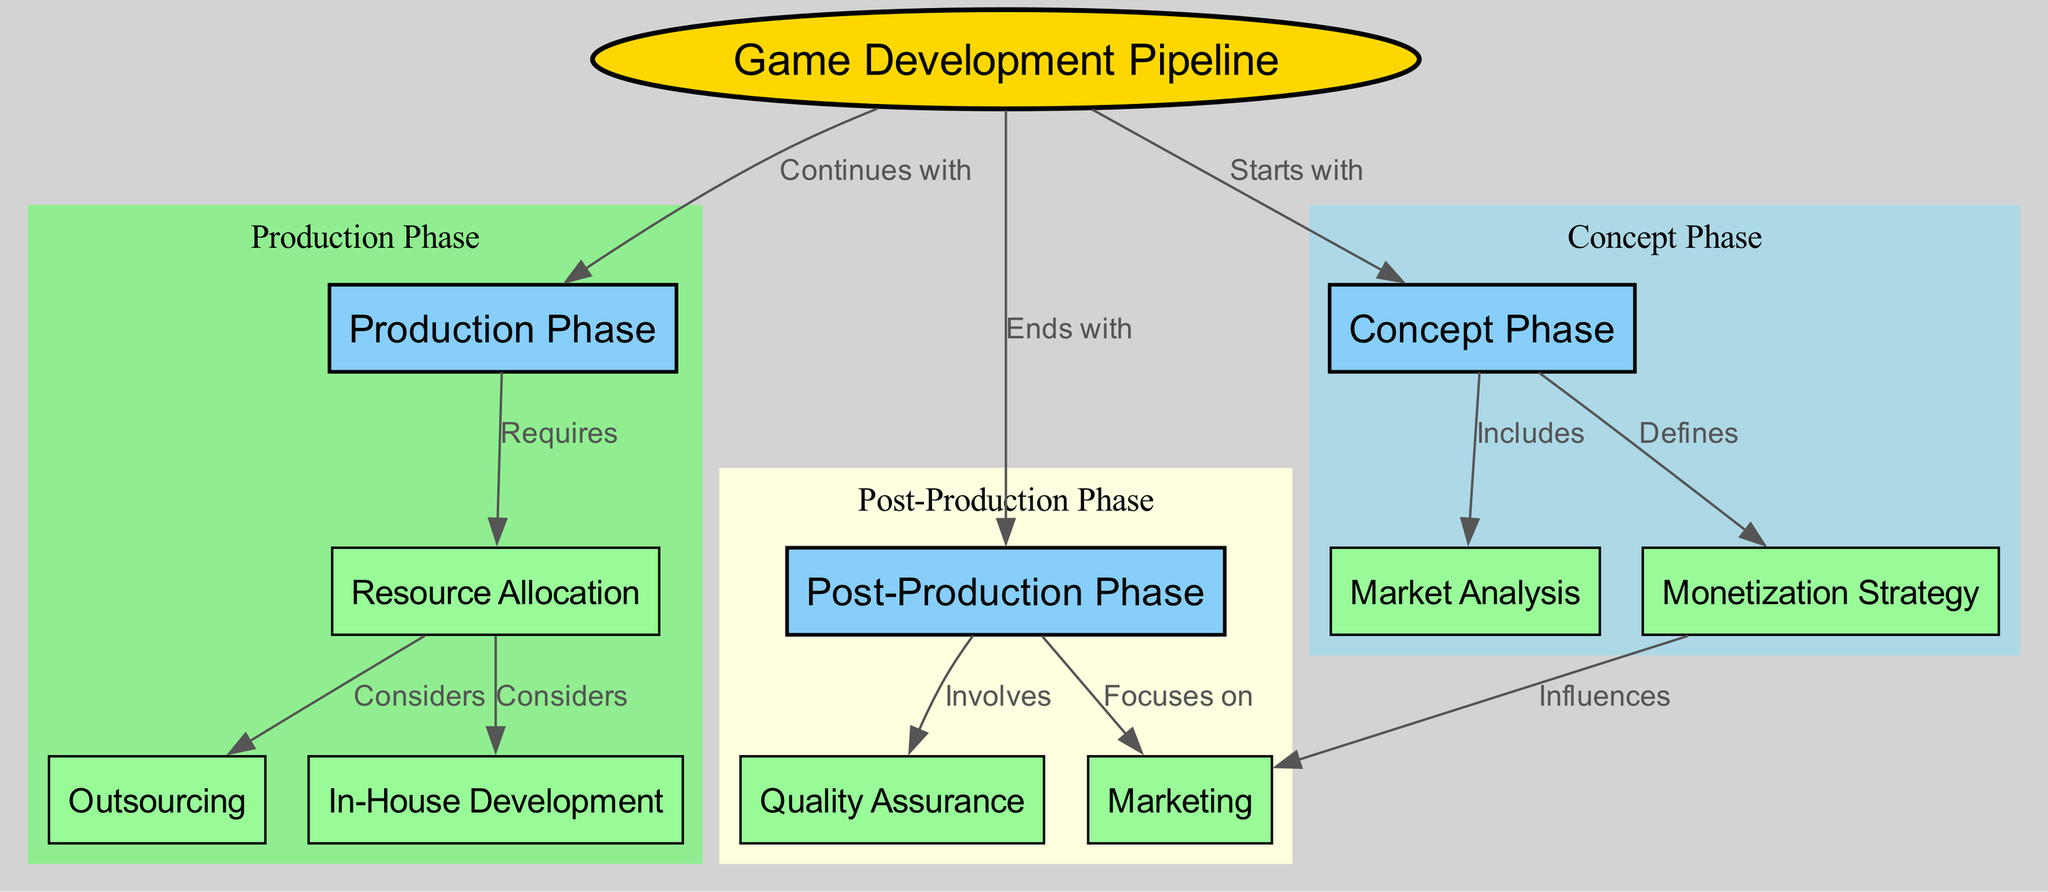What are the three phases of the game development pipeline? The diagram clearly defines three distinct phases of the game development pipeline. By examining the nodes connected to the main node, "Game Development Pipeline," we can identify the phases: "Concept Phase," "Production Phase," and "Post-Production Phase."
Answer: Concept Phase, Production Phase, Post-Production Phase What node does the production phase involve? In the diagram, the edges originating from the "Production Phase" node point to "Resource Allocation," "Outsourcing," and "In-House Development." Therefore, it is clear that these nodes are involved in the production phase.
Answer: Resource Allocation, Outsourcing, In-House Development Which strategy influences marketing? The diagram shows an edge from "Monetization Strategy" to "Marketing." This indicates that the monetization strategy plays a role in determining the marketing approach for the game.
Answer: Monetization Strategy How many edges are in the game development pipeline diagram? To determine the number of edges, we can count the direct connections between nodes. The diagram has a total of 10 edges connecting different nodes, indicating the relationships and flow between various elements of the game development pipeline.
Answer: 10 What includes the concept phase? According to the diagram, the "Concept Phase" node has an edge leading to "Market Analysis," indicating that market analysis is a key component included in this phase.
Answer: Market Analysis What does the post-production phase focus on? The diagram illustrates that the "Post-Production Phase" includes edges to both "Quality Assurance" and "Marketing." Therefore, it focuses primarily on these two aspects after the game development is complete.
Answer: Quality Assurance, Marketing What does the production phase require? Based on the diagram, the edge from the "Production Phase" to "Resource Allocation" signifies that the production phase explicitly requires resource allocation for its execution.
Answer: Resource Allocation What does the concept phase define? As represented in the diagram, the edge from "Concept Phase" to "Monetization Strategy" demonstrates that one of the outcomes of the concept phase is the definition of the monetization strategy for the game.
Answer: Monetization Strategy What connection does outsourcing have in the diagram? The diagram shows a dual connection of "Outsourcing" that branches from "Resource Allocation," indicating that outsourcing is an option that needs to be considered when allocating resources within the production phase.
Answer: Considers 